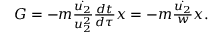<formula> <loc_0><loc_0><loc_500><loc_500>\begin{array} { r } { G = - m \frac { \dot { u _ { 2 } } } { u _ { 2 } ^ { 2 } } \frac { d t } { d \tau } x = - m \frac { \dot { u _ { 2 } } } { w } x . } \end{array}</formula> 